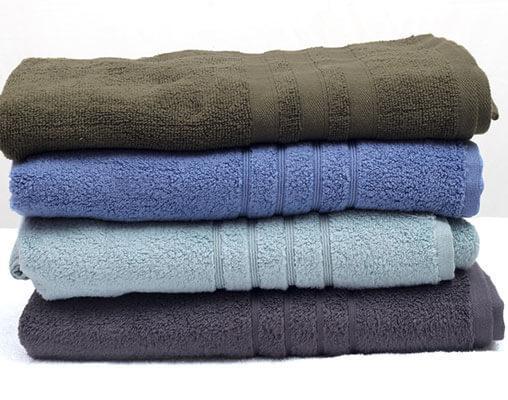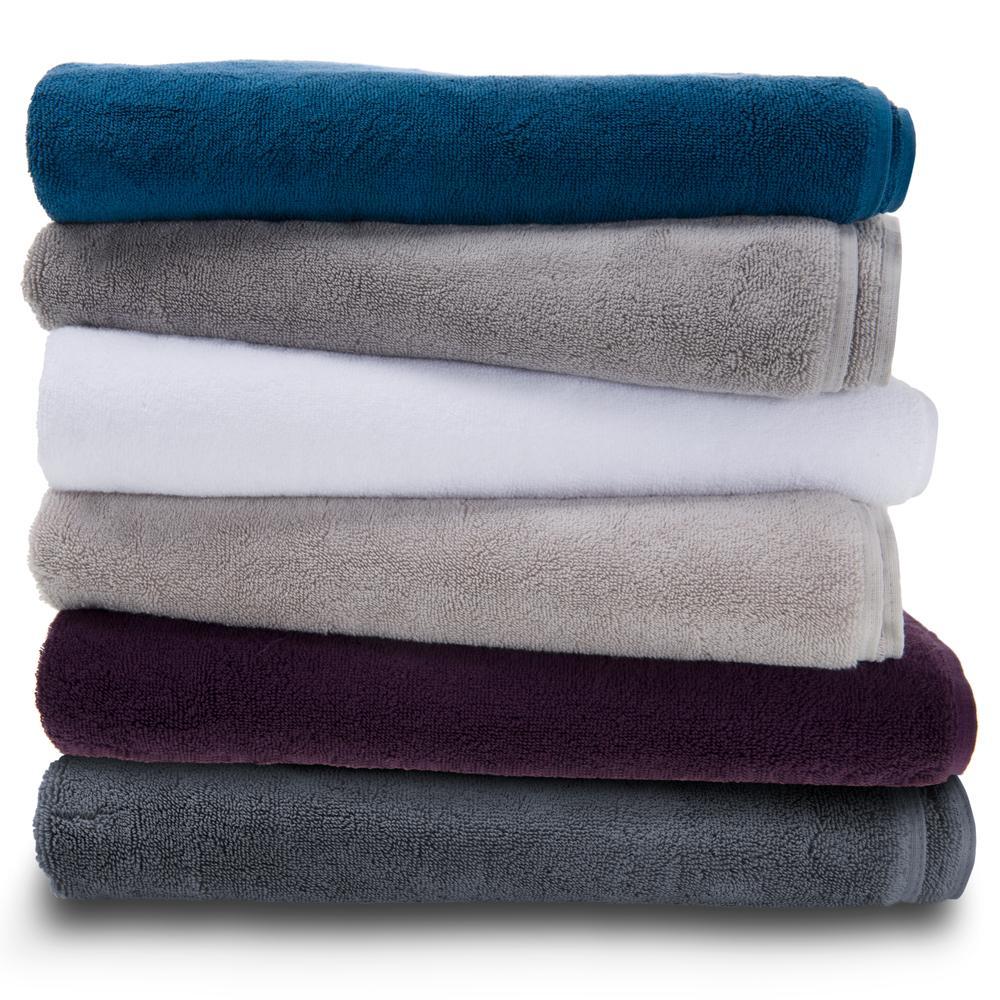The first image is the image on the left, the second image is the image on the right. Evaluate the accuracy of this statement regarding the images: "There are more towels in the right image than in the left image.". Is it true? Answer yes or no. Yes. The first image is the image on the left, the second image is the image on the right. Evaluate the accuracy of this statement regarding the images: "There are ten towels.". Is it true? Answer yes or no. Yes. 